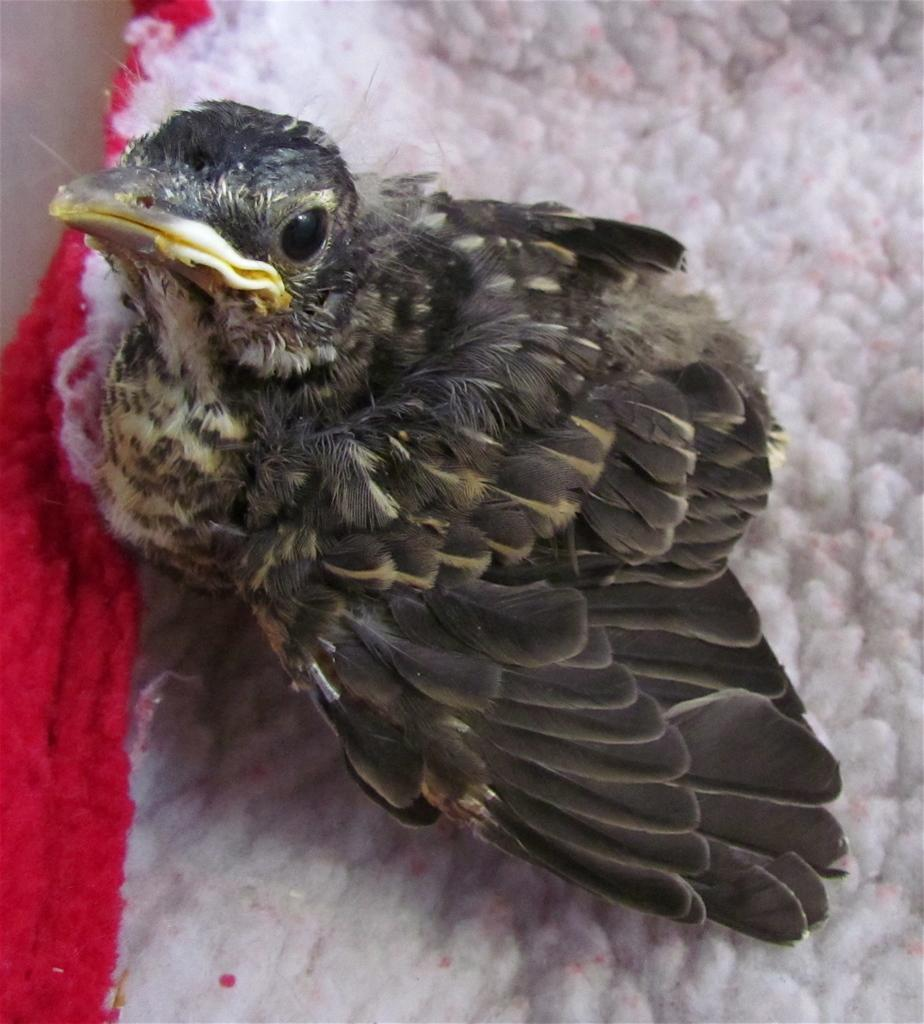What type of animal is in the image? There is a bird in the image. What colors can be seen on the bird? The bird is black and white in color. Where is the bird positioned in the image? The bird is in the front of the image. What is under the bird in the image? There is a red and white cloth under the bird. Can you tell me the weight of the toad on the scale in the image? There is no toad or scale present in the image; it features a bird and a red and white cloth. 